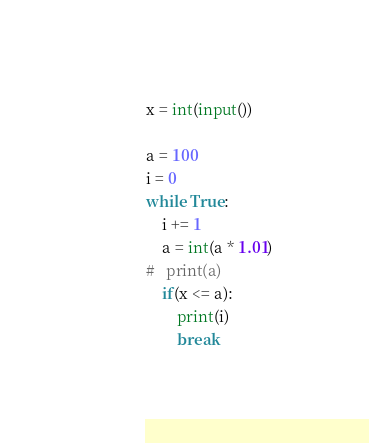<code> <loc_0><loc_0><loc_500><loc_500><_Python_>x = int(input())

a = 100
i = 0
while True:
	i += 1
	a = int(a * 1.01)
#	print(a)
	if(x <= a):
		print(i)
		break
</code> 